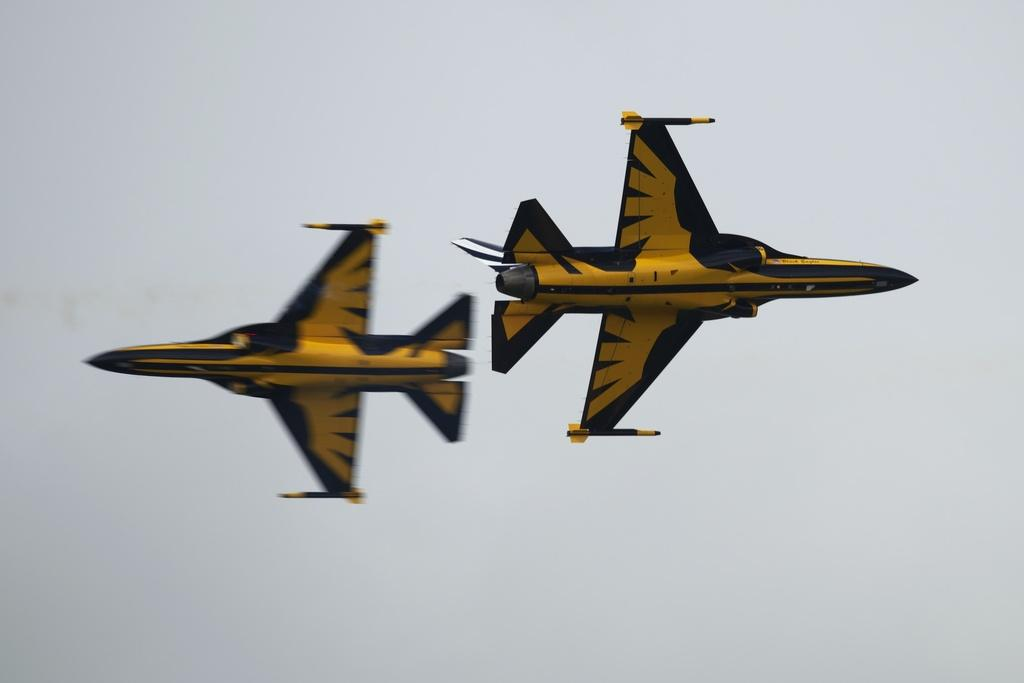What are the main subjects in the image? There are two aeroplanes in the image. Can you describe the colors of the aeroplanes? One aeroplane is yellow, and the other is black. What is the color of the background in the image? The background of the image is white. What type of story does the daughter tell about the yellow aeroplane in the image? There is no daughter or story present in the image; it only features two aeroplanes and a white background. 